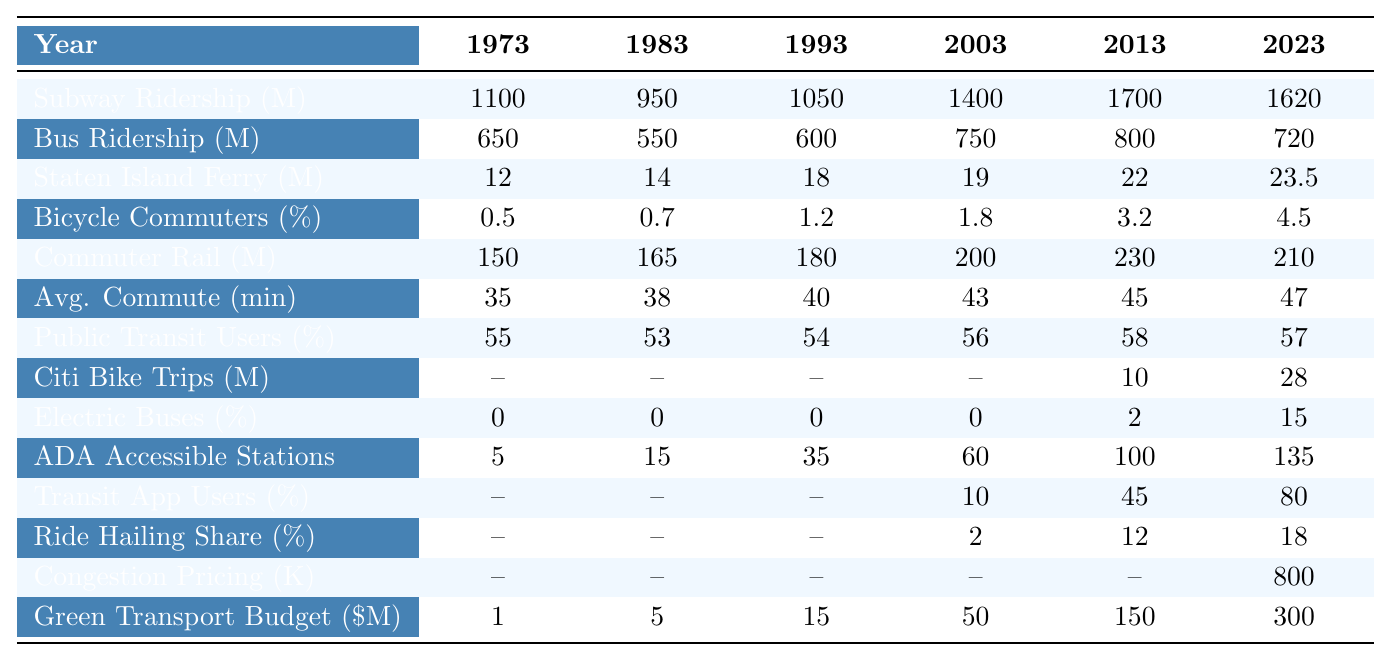What was the subway ridership in the year 2003? The table shows the subway ridership for the year 2003 as 1400000000, which can be found in the corresponding row for "Subway Ridership" under the column for 2003.
Answer: 1,400,000,000 In which year did the Staten Island Ferry ridership first exceed 20 million passengers? By analyzing the values in the "Staten Island Ferry" row, we can see that it first exceeded 20 million in 2013, as the numbers for 2013 (22 million) and 2012 (19 million) indicate.
Answer: 2013 What was the percentage change in bicycle commuter percentage from 1973 to 2023? The bicycle commuter percentage in 1973 was 0.5% and in 2023 it was 4.5%. The percentage change is calculated as ((4.5 - 0.5) / 0.5) * 100 = 800%.
Answer: 800% How does the average commute time in 2023 compare to that in 1973? The average commute time in 1973 was 35 minutes, and in 2023 it increased to 47 minutes. To find the difference, we subtract: 47 - 35 = 12 minutes.
Answer: 12 minutes What was the total public transit usage percentage in 2023? The table shows that the percentage using public transit in 2023 was 57%, which is directly listed under the relevant column.
Answer: 57% Has there been an increase in the number of ADA accessible subway stations from 1973 to 2023? Yes, in 1973 there were only 5 ADA accessible stations and in 2023 that number increased to 135.
Answer: Yes Calculate the average annual subway ridership over the years 1993 to 2023. The subway ridership for those years is 1050000000 (1993), 1400000000 (2003), 1700000000 (2013), and 1620000000 (2023). Adding these values gives 5,660,000,000, and dividing by 4 (number of years) gives an average of 1,415,000,000.
Answer: 1,415,000,000 What was the increase in the budget for green transportation initiatives from 1973 to 2023? The budget in 1973 was 1 million, and in 2023 it increased to 300 million. The increase is calculated as 300 - 1 = 299 million.
Answer: 299 million Does the percentage of electric buses in the fleet in 2023 represent a significant increase compared to 1973? Yes, in 1973 the percentage of electric buses was 0%, and by 2023 it rose to 15%, indicating significant growth.
Answer: Yes Which year had the highest commuter rail ridership, and what was the value? The highest commuter rail ridership occurred in 2013 with a value of 230 million, as seen in the "Commuter Rail" row under that year’s column.
Answer: 230 million 